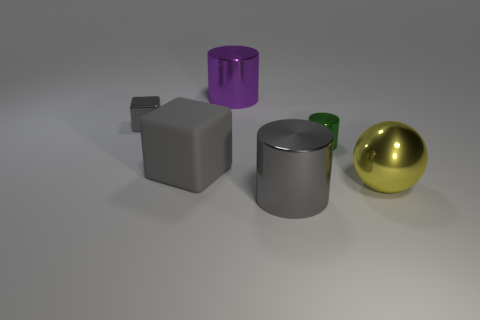Is there anything else that is made of the same material as the large gray block?
Give a very brief answer. No. How many objects are metallic blocks or objects that are on the left side of the big metal sphere?
Offer a very short reply. 5. Is the color of the tiny metal block the same as the matte object that is to the left of the purple metal cylinder?
Your answer should be compact. Yes. There is a gray object that is both in front of the small green object and behind the big yellow shiny ball; what size is it?
Keep it short and to the point. Large. Are there any purple metallic things in front of the big yellow sphere?
Provide a short and direct response. No. There is a metallic thing that is in front of the big yellow shiny ball; is there a tiny green metal cylinder that is behind it?
Make the answer very short. Yes. Are there an equal number of big spheres to the left of the big purple cylinder and cylinders behind the large yellow metal ball?
Your response must be concise. No. There is a sphere that is made of the same material as the large purple thing; what color is it?
Keep it short and to the point. Yellow. Are there any small red spheres made of the same material as the tiny green object?
Offer a terse response. No. What number of things are large blocks or purple objects?
Your response must be concise. 2. 